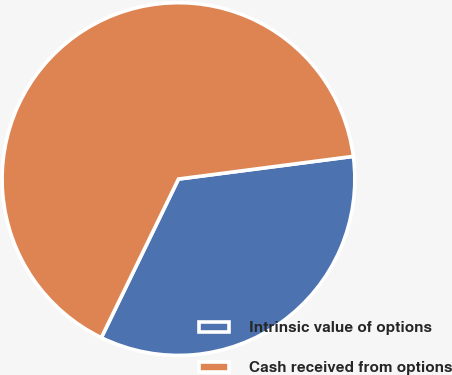<chart> <loc_0><loc_0><loc_500><loc_500><pie_chart><fcel>Intrinsic value of options<fcel>Cash received from options<nl><fcel>34.26%<fcel>65.74%<nl></chart> 